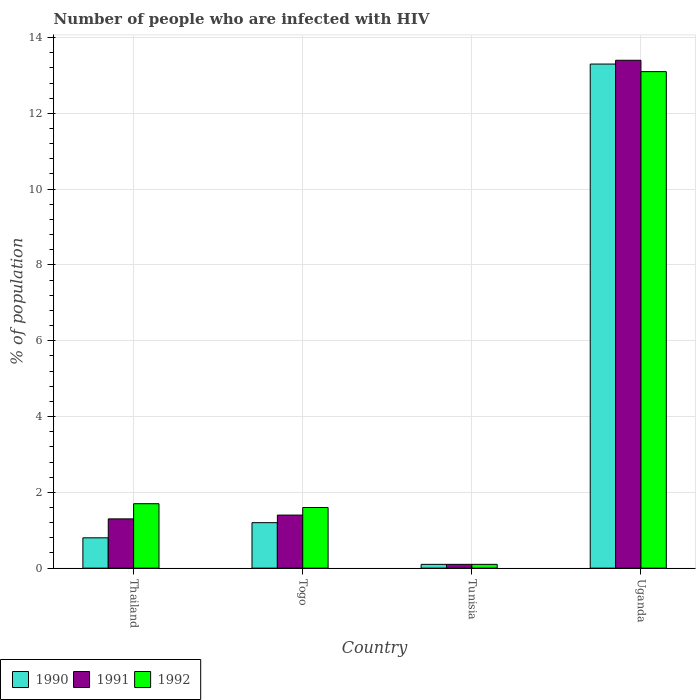How many different coloured bars are there?
Your answer should be compact. 3. Are the number of bars per tick equal to the number of legend labels?
Your answer should be very brief. Yes. How many bars are there on the 2nd tick from the left?
Make the answer very short. 3. How many bars are there on the 1st tick from the right?
Offer a terse response. 3. What is the label of the 1st group of bars from the left?
Your answer should be very brief. Thailand. In how many cases, is the number of bars for a given country not equal to the number of legend labels?
Offer a very short reply. 0. Across all countries, what is the minimum percentage of HIV infected population in in 1992?
Provide a short and direct response. 0.1. In which country was the percentage of HIV infected population in in 1992 maximum?
Provide a short and direct response. Uganda. In which country was the percentage of HIV infected population in in 1991 minimum?
Provide a succinct answer. Tunisia. What is the difference between the percentage of HIV infected population in in 1991 in Togo and that in Uganda?
Your answer should be compact. -12. What is the average percentage of HIV infected population in in 1991 per country?
Give a very brief answer. 4.05. What is the difference between the percentage of HIV infected population in of/in 1991 and percentage of HIV infected population in of/in 1992 in Uganda?
Keep it short and to the point. 0.3. In how many countries, is the percentage of HIV infected population in in 1990 greater than 13.6 %?
Provide a succinct answer. 0. What is the ratio of the percentage of HIV infected population in in 1992 in Thailand to that in Uganda?
Your answer should be very brief. 0.13. Is the difference between the percentage of HIV infected population in in 1991 in Thailand and Uganda greater than the difference between the percentage of HIV infected population in in 1992 in Thailand and Uganda?
Your answer should be compact. No. What is the difference between the highest and the second highest percentage of HIV infected population in in 1992?
Offer a terse response. -11.4. What does the 3rd bar from the right in Uganda represents?
Give a very brief answer. 1990. Are all the bars in the graph horizontal?
Your response must be concise. No. What is the difference between two consecutive major ticks on the Y-axis?
Your answer should be very brief. 2. Are the values on the major ticks of Y-axis written in scientific E-notation?
Provide a short and direct response. No. Does the graph contain any zero values?
Make the answer very short. No. Does the graph contain grids?
Ensure brevity in your answer.  Yes. Where does the legend appear in the graph?
Your answer should be compact. Bottom left. How many legend labels are there?
Keep it short and to the point. 3. How are the legend labels stacked?
Offer a terse response. Horizontal. What is the title of the graph?
Your answer should be compact. Number of people who are infected with HIV. Does "2007" appear as one of the legend labels in the graph?
Offer a terse response. No. What is the label or title of the Y-axis?
Offer a very short reply. % of population. What is the % of population of 1990 in Thailand?
Provide a short and direct response. 0.8. What is the % of population of 1991 in Thailand?
Your answer should be compact. 1.3. What is the % of population of 1992 in Thailand?
Offer a terse response. 1.7. What is the % of population in 1990 in Togo?
Provide a short and direct response. 1.2. What is the % of population of 1991 in Tunisia?
Your response must be concise. 0.1. Across all countries, what is the maximum % of population of 1990?
Your answer should be compact. 13.3. Across all countries, what is the minimum % of population in 1990?
Keep it short and to the point. 0.1. Across all countries, what is the minimum % of population of 1992?
Your answer should be compact. 0.1. What is the total % of population in 1990 in the graph?
Give a very brief answer. 15.4. What is the difference between the % of population of 1990 in Thailand and that in Togo?
Offer a terse response. -0.4. What is the difference between the % of population of 1992 in Thailand and that in Togo?
Give a very brief answer. 0.1. What is the difference between the % of population in 1990 in Thailand and that in Tunisia?
Your answer should be compact. 0.7. What is the difference between the % of population in 1990 in Thailand and that in Uganda?
Your response must be concise. -12.5. What is the difference between the % of population in 1990 in Togo and that in Tunisia?
Your answer should be compact. 1.1. What is the difference between the % of population in 1992 in Togo and that in Tunisia?
Keep it short and to the point. 1.5. What is the difference between the % of population of 1990 in Togo and that in Uganda?
Provide a succinct answer. -12.1. What is the difference between the % of population of 1990 in Thailand and the % of population of 1991 in Togo?
Your answer should be very brief. -0.6. What is the difference between the % of population in 1990 in Thailand and the % of population in 1992 in Togo?
Offer a very short reply. -0.8. What is the difference between the % of population in 1990 in Thailand and the % of population in 1991 in Uganda?
Give a very brief answer. -12.6. What is the difference between the % of population in 1990 in Thailand and the % of population in 1992 in Uganda?
Keep it short and to the point. -12.3. What is the difference between the % of population of 1990 in Togo and the % of population of 1991 in Tunisia?
Ensure brevity in your answer.  1.1. What is the difference between the % of population of 1990 in Togo and the % of population of 1991 in Uganda?
Provide a short and direct response. -12.2. What is the difference between the % of population of 1990 in Togo and the % of population of 1992 in Uganda?
Your response must be concise. -11.9. What is the difference between the % of population of 1991 in Tunisia and the % of population of 1992 in Uganda?
Provide a succinct answer. -13. What is the average % of population of 1990 per country?
Ensure brevity in your answer.  3.85. What is the average % of population of 1991 per country?
Your answer should be very brief. 4.05. What is the average % of population in 1992 per country?
Your answer should be very brief. 4.12. What is the difference between the % of population of 1990 and % of population of 1991 in Thailand?
Offer a very short reply. -0.5. What is the difference between the % of population of 1990 and % of population of 1992 in Thailand?
Your answer should be very brief. -0.9. What is the difference between the % of population of 1990 and % of population of 1991 in Togo?
Offer a terse response. -0.2. What is the difference between the % of population in 1991 and % of population in 1992 in Togo?
Make the answer very short. -0.2. What is the difference between the % of population in 1990 and % of population in 1992 in Tunisia?
Offer a very short reply. 0. What is the difference between the % of population of 1991 and % of population of 1992 in Tunisia?
Your response must be concise. 0. What is the difference between the % of population of 1990 and % of population of 1991 in Uganda?
Offer a terse response. -0.1. What is the difference between the % of population of 1990 and % of population of 1992 in Uganda?
Your answer should be very brief. 0.2. What is the ratio of the % of population of 1990 in Thailand to that in Togo?
Give a very brief answer. 0.67. What is the ratio of the % of population of 1991 in Thailand to that in Togo?
Ensure brevity in your answer.  0.93. What is the ratio of the % of population of 1990 in Thailand to that in Uganda?
Keep it short and to the point. 0.06. What is the ratio of the % of population in 1991 in Thailand to that in Uganda?
Ensure brevity in your answer.  0.1. What is the ratio of the % of population of 1992 in Thailand to that in Uganda?
Keep it short and to the point. 0.13. What is the ratio of the % of population in 1990 in Togo to that in Tunisia?
Give a very brief answer. 12. What is the ratio of the % of population in 1991 in Togo to that in Tunisia?
Provide a short and direct response. 14. What is the ratio of the % of population of 1992 in Togo to that in Tunisia?
Your response must be concise. 16. What is the ratio of the % of population in 1990 in Togo to that in Uganda?
Your answer should be compact. 0.09. What is the ratio of the % of population in 1991 in Togo to that in Uganda?
Offer a terse response. 0.1. What is the ratio of the % of population in 1992 in Togo to that in Uganda?
Your response must be concise. 0.12. What is the ratio of the % of population of 1990 in Tunisia to that in Uganda?
Provide a short and direct response. 0.01. What is the ratio of the % of population of 1991 in Tunisia to that in Uganda?
Your answer should be compact. 0.01. What is the ratio of the % of population in 1992 in Tunisia to that in Uganda?
Provide a succinct answer. 0.01. 